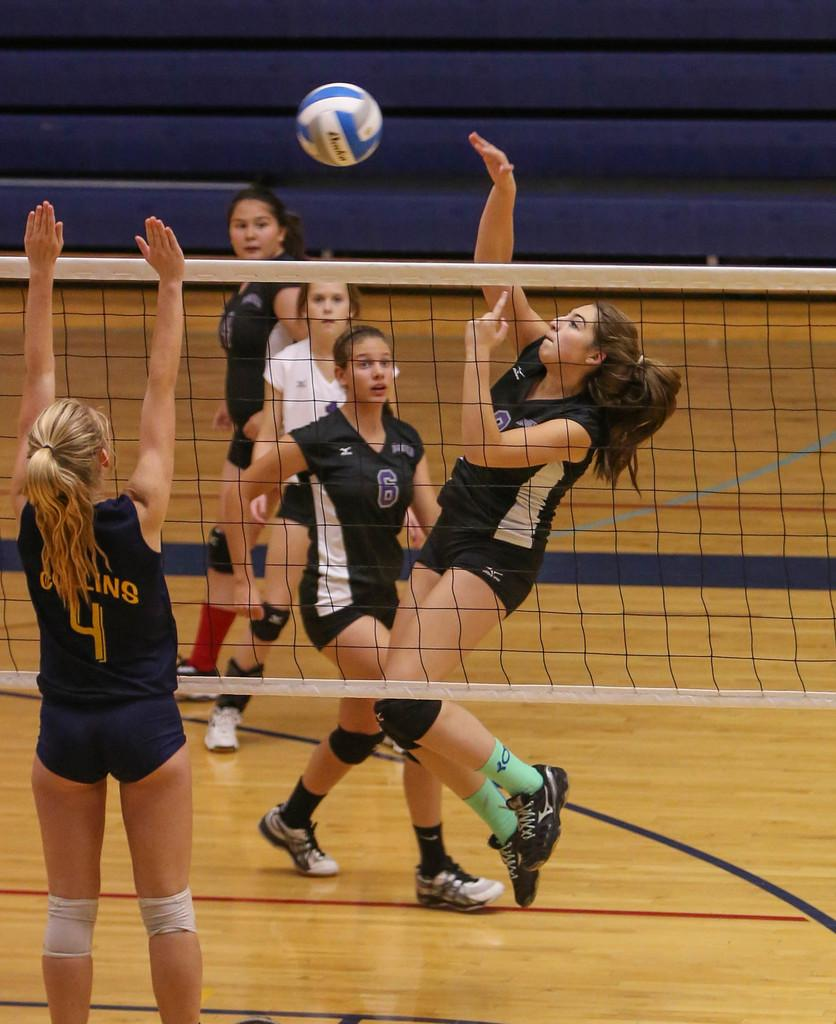Who is present in the image? There are girls in the image. What are the girls doing in the image? The girls are playing volleyball. What is the main feature in the foreground of the image? There is a net in the foreground area of the image. What type of circle can be seen on the girls' legs in the image? There is no circle visible on the girls' legs in the image. 